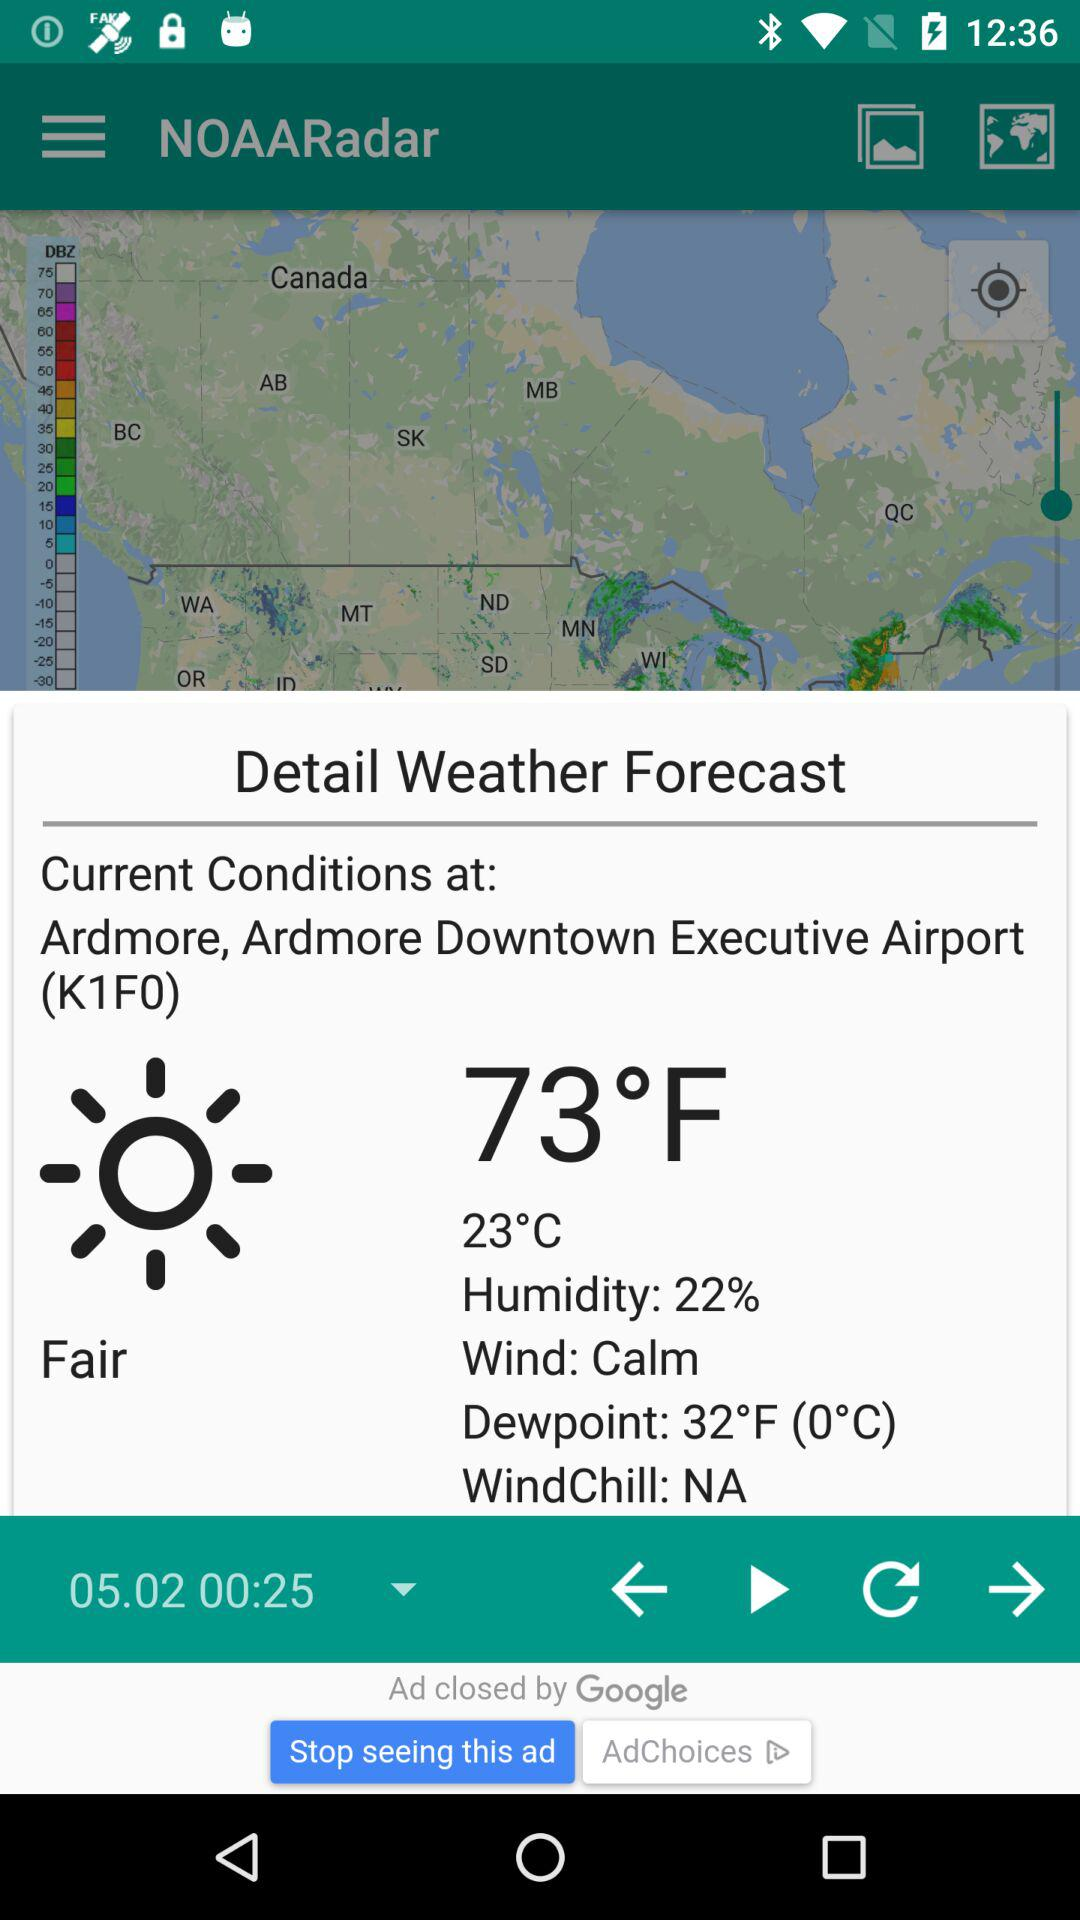What is the current location? The current location is Ardmore, Ardmore Downtown Executive Airport(K1F0). 